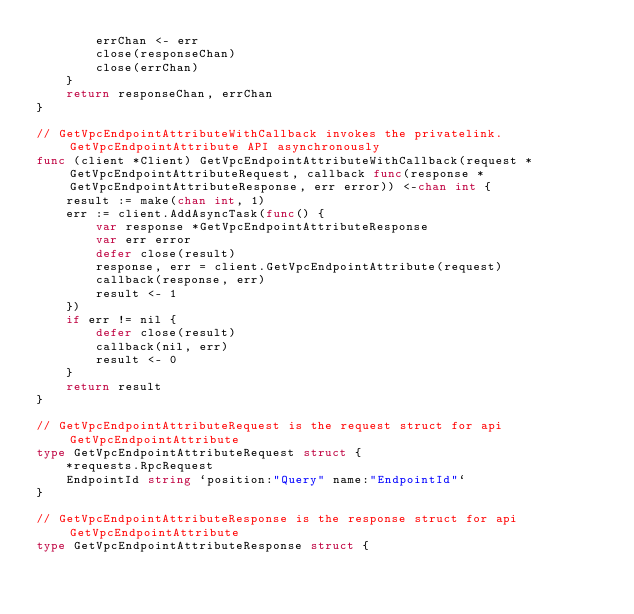Convert code to text. <code><loc_0><loc_0><loc_500><loc_500><_Go_>		errChan <- err
		close(responseChan)
		close(errChan)
	}
	return responseChan, errChan
}

// GetVpcEndpointAttributeWithCallback invokes the privatelink.GetVpcEndpointAttribute API asynchronously
func (client *Client) GetVpcEndpointAttributeWithCallback(request *GetVpcEndpointAttributeRequest, callback func(response *GetVpcEndpointAttributeResponse, err error)) <-chan int {
	result := make(chan int, 1)
	err := client.AddAsyncTask(func() {
		var response *GetVpcEndpointAttributeResponse
		var err error
		defer close(result)
		response, err = client.GetVpcEndpointAttribute(request)
		callback(response, err)
		result <- 1
	})
	if err != nil {
		defer close(result)
		callback(nil, err)
		result <- 0
	}
	return result
}

// GetVpcEndpointAttributeRequest is the request struct for api GetVpcEndpointAttribute
type GetVpcEndpointAttributeRequest struct {
	*requests.RpcRequest
	EndpointId string `position:"Query" name:"EndpointId"`
}

// GetVpcEndpointAttributeResponse is the response struct for api GetVpcEndpointAttribute
type GetVpcEndpointAttributeResponse struct {</code> 